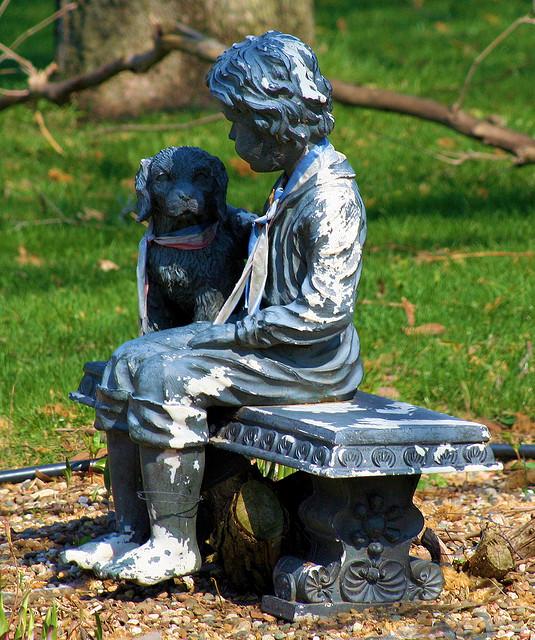Is there a branch on the ground?
Be succinct. Yes. Is that a real person sitting on the bench?
Answer briefly. No. What animal is the statue?
Give a very brief answer. Dog. 